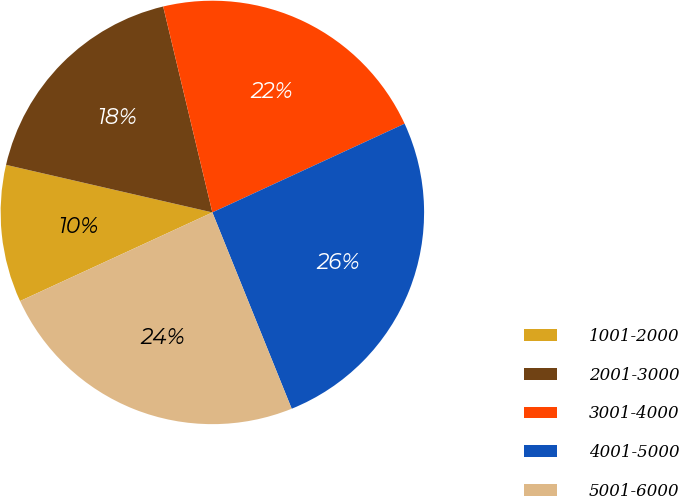Convert chart to OTSL. <chart><loc_0><loc_0><loc_500><loc_500><pie_chart><fcel>1001-2000<fcel>2001-3000<fcel>3001-4000<fcel>4001-5000<fcel>5001-6000<nl><fcel>10.48%<fcel>17.66%<fcel>21.85%<fcel>25.77%<fcel>24.24%<nl></chart> 